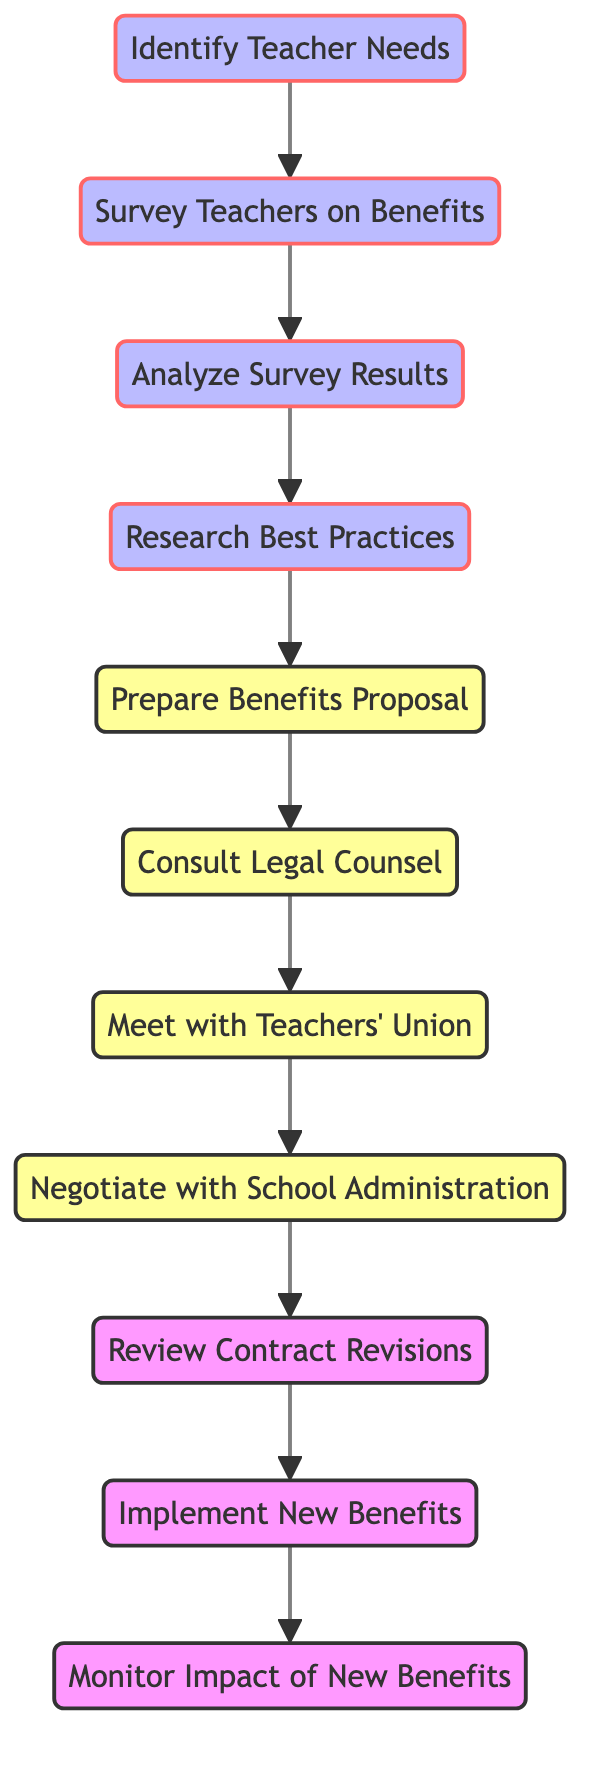What is the starting point in the directed graph? The starting point in the directed graph is the node labeled "Identify Teacher Needs." This is the first node that initiates the process outlined in the diagram.
Answer: Identify Teacher Needs How many total nodes are present in the diagram? By counting each unique node listed, there are 11 nodes in total that represent different steps in the advocacy process.
Answer: 11 Which node comes immediately after "Survey Teachers on Benefits"? Following the directed edges in the graph, "Analyze Survey Results" directly comes after "Survey Teachers on Benefits." This indicates the next step in the process after surveying.
Answer: Analyze Survey Results What step directly precedes "Negotiate with School Administration"? According to the flow of the directed graph, the step that directly precedes "Negotiate with School Administration" is "Meet with Teachers' Union." This shows the requirement for union involvement before negotiations.
Answer: Meet with Teachers' Union Which two nodes are sequentially connected to "Prepare Benefits Proposal"? The nodes that are sequentially connected to "Prepare Benefits Proposal" are "Research Best Practices" (which comes before) and "Consult Legal Counsel" (which follows after). Both are important steps in preparing the proposal.
Answer: Research Best Practices, Consult Legal Counsel How many edges connect the nodes in the diagram? The edges are the connections between nodes, and by counting each connection listed, there are 10 edges that depict the relationships and flow from one node to another.
Answer: 10 What is the last step shown in the directed graph? The last step in the sequence illustrated by the directed graph is "Monitor Impact of New Benefits." This indicates that once new benefits are implemented, their effects will be monitored.
Answer: Monitor Impact of New Benefits What type of question does the directed graph primarily address? The directed graph primarily addresses procedural steps taken in advocating for teacher benefits, showing the necessary steps from identifying needs to implementing them. This is a process-oriented question type.
Answer: Process-oriented Which node is the only one to connect to "Review Contract Revisions"? In the flow of the diagram, the node that exclusively connects to "Review Contract Revisions" is "Negotiate with School Administration." This shows that negotiations must happen before reviewing contract revisions.
Answer: Negotiate with School Administration 